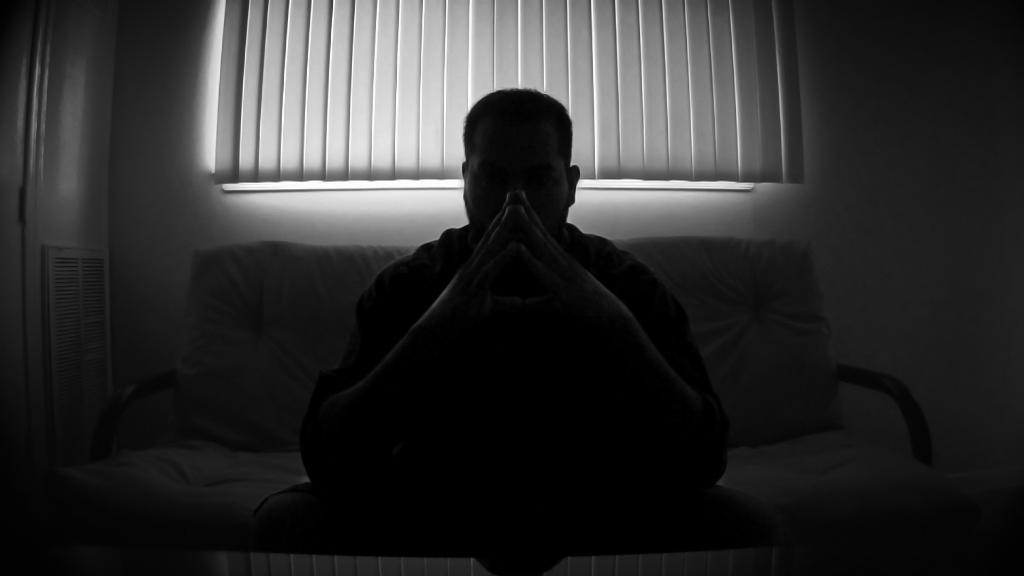Can you describe this image briefly? This is a black and white image. Here I can see a person sitting on a couch. In the background there is a curtain to the window. This is an image clicked in the dark and it is an inside view of a room. 